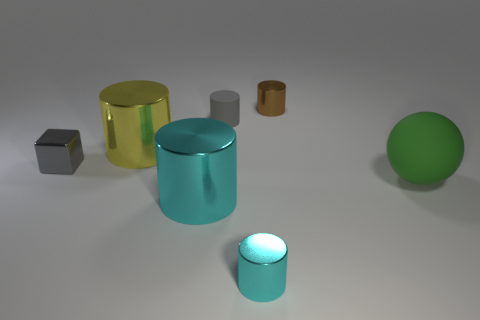Subtract 2 cylinders. How many cylinders are left? 3 Subtract all tiny gray cylinders. How many cylinders are left? 4 Subtract all gray cylinders. How many cylinders are left? 4 Subtract all red cylinders. Subtract all green spheres. How many cylinders are left? 5 Add 1 small blocks. How many objects exist? 8 Subtract all balls. How many objects are left? 6 Subtract all small brown metal objects. Subtract all gray things. How many objects are left? 4 Add 4 big green matte spheres. How many big green matte spheres are left? 5 Add 4 small cyan cylinders. How many small cyan cylinders exist? 5 Subtract 0 cyan spheres. How many objects are left? 7 